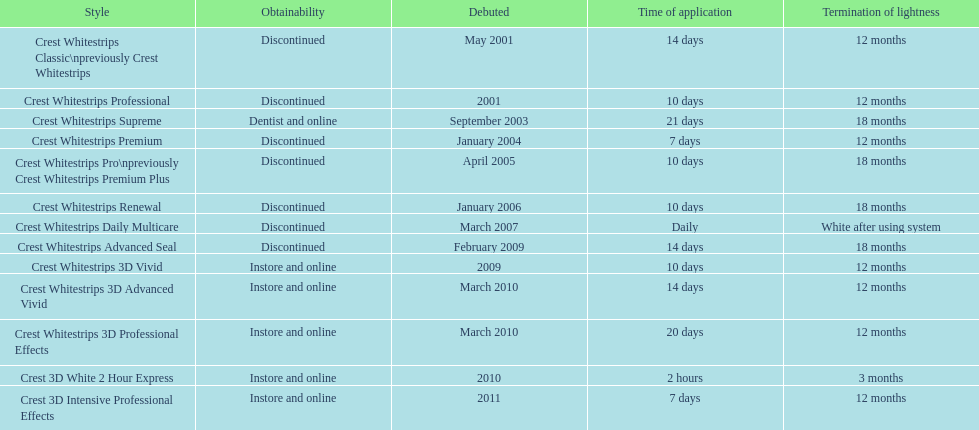Which discontinued product was introduced the same year as crest whitestrips 3d vivid? Crest Whitestrips Advanced Seal. 